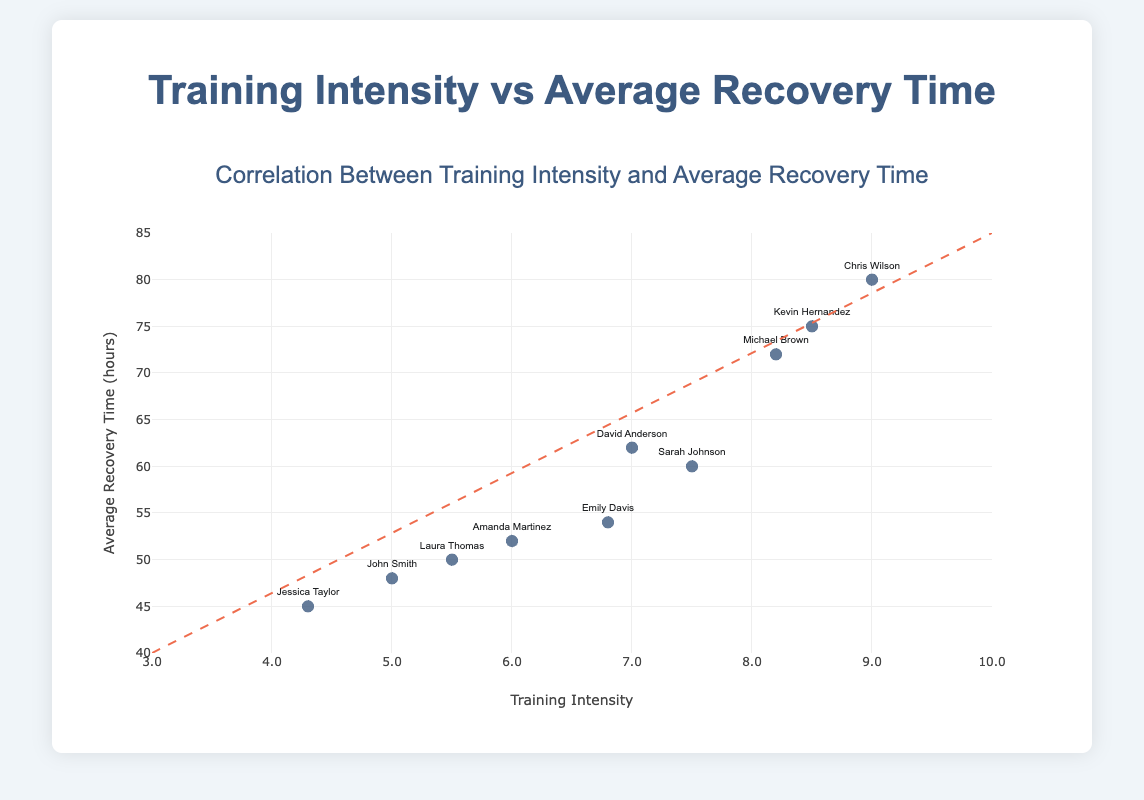What is the title of the plot? The title is located at the top center of the plot and is usually larger and bolder than other text elements.
Answer: Correlation Between Training Intensity and Average Recovery Time How many data points are there in the plot? Count the number of markers (points) present in the scatter plot.
Answer: 10 What is the training intensity of Chris Wilson? Locate the marker labeled "Chris Wilson" and read the x-axis value corresponding to it.
Answer: 9.0 Which client has the shortest average recovery time? Identify the marker positioned lowest on the y-axis and check the label associated with it.
Answer: Jessica Taylor What is the y-axis range? Read the scale provided alongside the y-axis to determine the starting and ending values.
Answer: 40 to 85 What is the average recovery time for training intensity of 6.0? Locate the marker at x = 6.0 and read the corresponding y-axis value. The client associated with this data point is Amanda Martinez, and the average recovery time is shown as 52 hours.
Answer: 52 Which client has the highest training intensity? Identify the rightmost marker on the x-axis and check the label associated with it.
Answer: Chris Wilson What is the relationship shown by the trendline? Observe the direction and slope of the trend line added to the plot. It has a dashed appearance and is sloping upwards from left to right, indicating that as training intensity increases, average recovery time also increases.
Answer: Positive correlation How many clients have a training intensity above 7.0? Count the number of markers situated to the right of the vertical line at x=7.0.
Answer: 5 What is the range of average recovery time for clients with a training intensity of 7.0 or higher? Identify the markers at or above the training intensity of 7.0 and find their corresponding y-axis values. The range is from the lowest to the highest value within these points, i.e., from 60 to 80 hours.
Answer: 60 to 80 